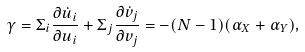Convert formula to latex. <formula><loc_0><loc_0><loc_500><loc_500>\gamma = \Sigma _ { i } \frac { \partial \dot { u } _ { i } } { \partial u _ { i } } + \Sigma _ { j } \frac { \partial \dot { v } _ { j } } { \partial v _ { j } } = - ( N - 1 ) ( \alpha _ { X } + \alpha _ { Y } ) ,</formula> 